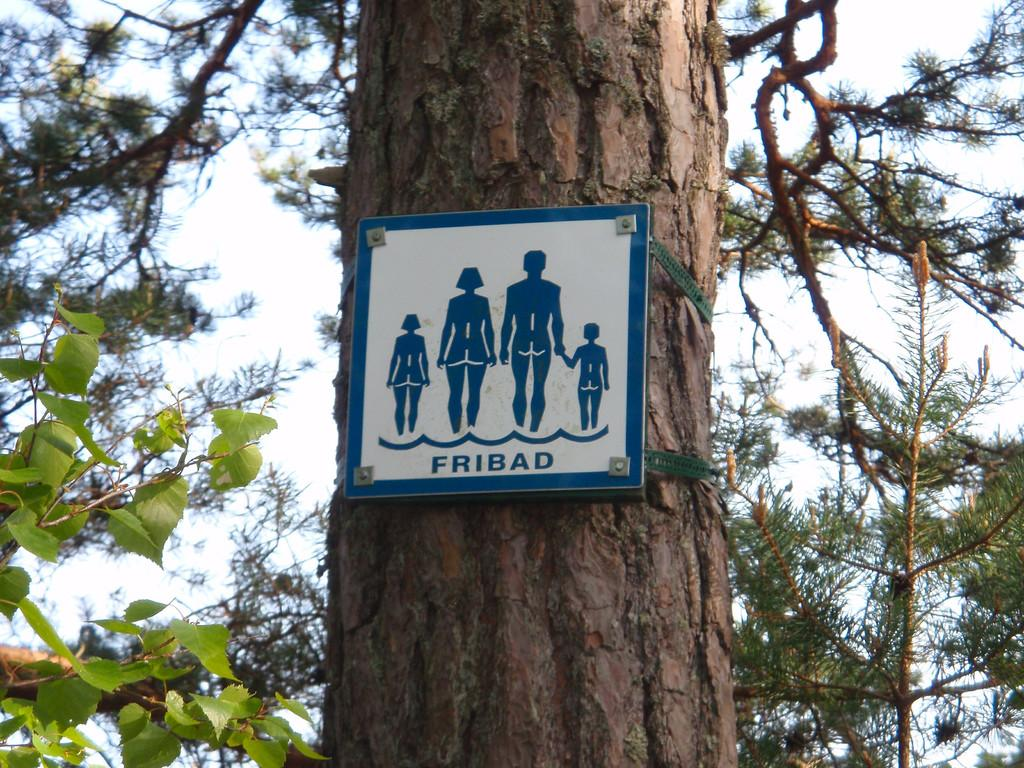What is the main subject in the middle of the image? There is a tree trunk in the middle of the image. What is placed on the tree trunk? There is a board on the tree trunk. What type of vegetation is on the left side of the image? There are green leaves on the left side of the image. What is visible in the background of the image? The sky is visible in the image. What type of lettuce is growing on the tree trunk in the image? There is no lettuce present in the image; the tree trunk has green leaves on the left side. 